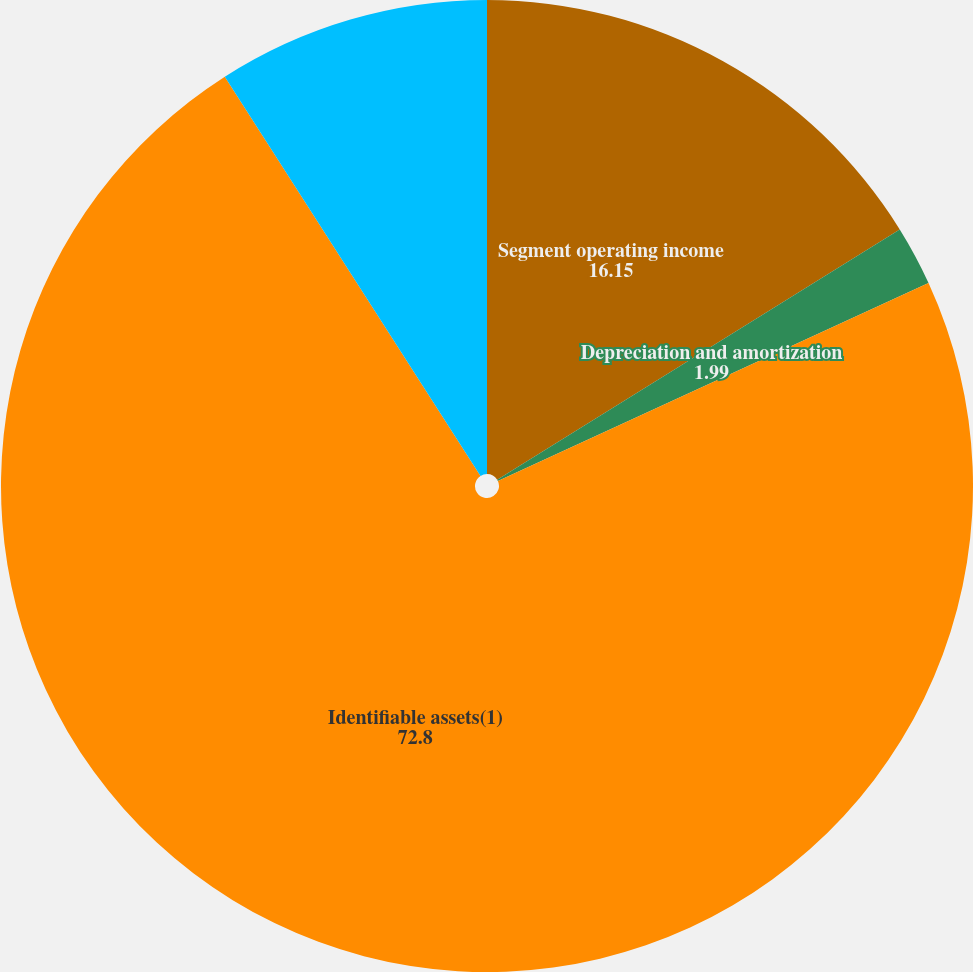Convert chart to OTSL. <chart><loc_0><loc_0><loc_500><loc_500><pie_chart><fcel>Segment operating income<fcel>Depreciation and amortization<fcel>Identifiable assets(1)<fcel>Capital expenditures<nl><fcel>16.15%<fcel>1.99%<fcel>72.8%<fcel>9.07%<nl></chart> 